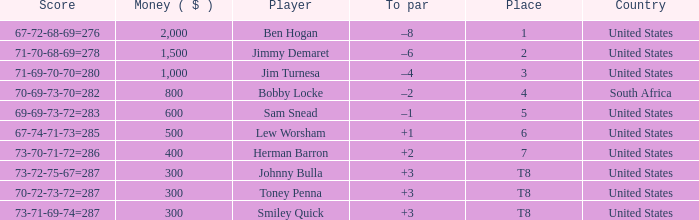I'm looking to parse the entire table for insights. Could you assist me with that? {'header': ['Score', 'Money ( $ )', 'Player', 'To par', 'Place', 'Country'], 'rows': [['67-72-68-69=276', '2,000', 'Ben Hogan', '–8', '1', 'United States'], ['71-70-68-69=278', '1,500', 'Jimmy Demaret', '–6', '2', 'United States'], ['71-69-70-70=280', '1,000', 'Jim Turnesa', '–4', '3', 'United States'], ['70-69-73-70=282', '800', 'Bobby Locke', '–2', '4', 'South Africa'], ['69-69-73-72=283', '600', 'Sam Snead', '–1', '5', 'United States'], ['67-74-71-73=285', '500', 'Lew Worsham', '+1', '6', 'United States'], ['73-70-71-72=286', '400', 'Herman Barron', '+2', '7', 'United States'], ['73-72-75-67=287', '300', 'Johnny Bulla', '+3', 'T8', 'United States'], ['70-72-73-72=287', '300', 'Toney Penna', '+3', 'T8', 'United States'], ['73-71-69-74=287', '300', 'Smiley Quick', '+3', 'T8', 'United States']]} What is the 5th place player's financial status? 600.0. 